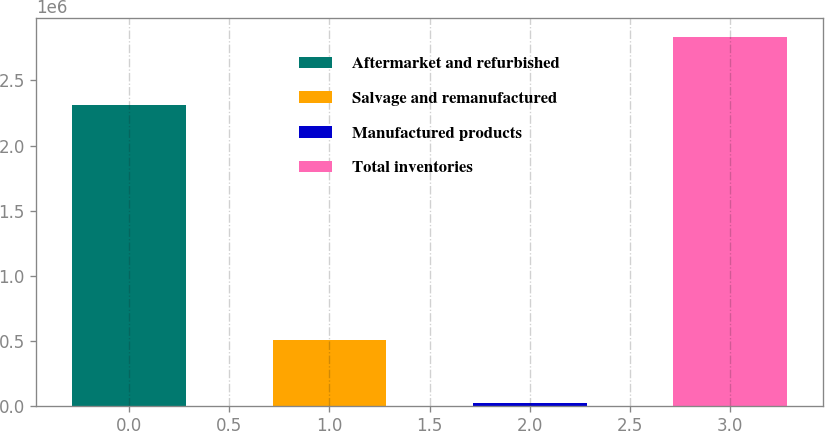Convert chart. <chart><loc_0><loc_0><loc_500><loc_500><bar_chart><fcel>Aftermarket and refurbished<fcel>Salvage and remanufactured<fcel>Manufactured products<fcel>Total inventories<nl><fcel>2.30946e+06<fcel>503199<fcel>23418<fcel>2.83608e+06<nl></chart> 